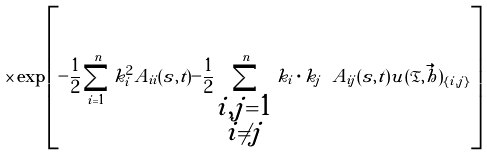<formula> <loc_0><loc_0><loc_500><loc_500>\times \exp \left [ - \frac { 1 } { 2 } \sum _ { i = 1 } ^ { n } k _ { i } ^ { 2 } A _ { i i } ( s , t ) - \frac { 1 } { 2 } \sum _ { \substack { i , j = 1 \\ i \neq j } } ^ { n } k _ { i } \cdot k _ { j } \ A _ { i j } ( s , t ) u ( \mathfrak { T } , \vec { h } ) _ { \{ i , j \} } \right ]</formula> 